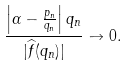Convert formula to latex. <formula><loc_0><loc_0><loc_500><loc_500>\frac { \left | \alpha - \frac { p _ { n } } { q _ { n } } \right | q _ { n } } { | \widehat { f } ( q _ { n } ) | } \to 0 .</formula> 